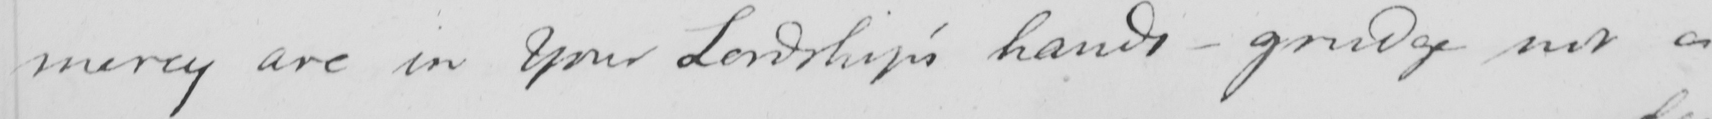Can you read and transcribe this handwriting? mercy are in Your Lordship ' s hands  _  grudge not a 